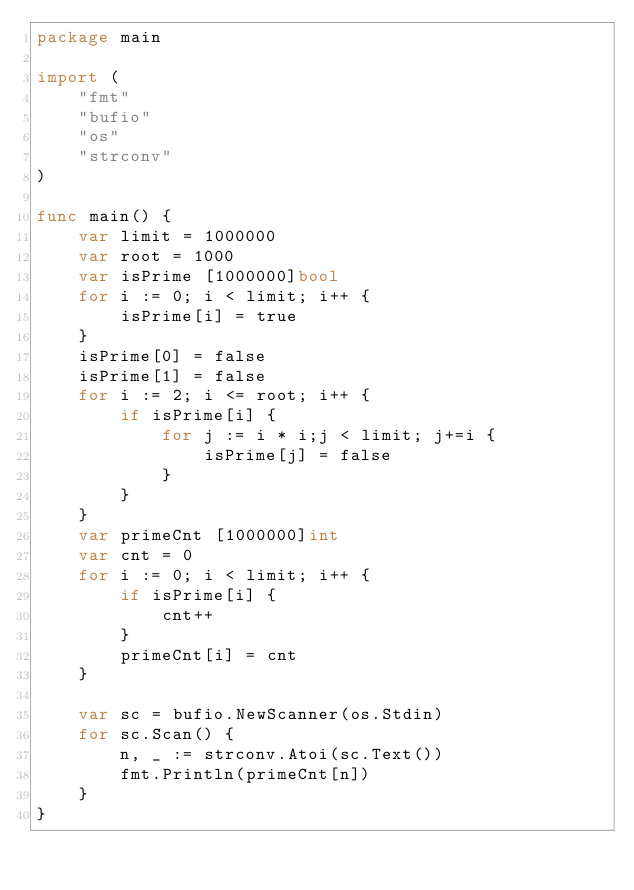Convert code to text. <code><loc_0><loc_0><loc_500><loc_500><_Go_>package main

import (
    "fmt"
    "bufio"
    "os"
    "strconv"
)

func main() {
    var limit = 1000000
    var root = 1000
    var isPrime [1000000]bool
    for i := 0; i < limit; i++ {
        isPrime[i] = true
    }
    isPrime[0] = false
    isPrime[1] = false
    for i := 2; i <= root; i++ {
        if isPrime[i] {
            for j := i * i;j < limit; j+=i {
                isPrime[j] = false
            }
        }
    }
    var primeCnt [1000000]int
    var cnt = 0
    for i := 0; i < limit; i++ {
        if isPrime[i] {
            cnt++
        }
        primeCnt[i] = cnt
    }

    var sc = bufio.NewScanner(os.Stdin)
    for sc.Scan() {
        n, _ := strconv.Atoi(sc.Text())
        fmt.Println(primeCnt[n])
    }
}
</code> 